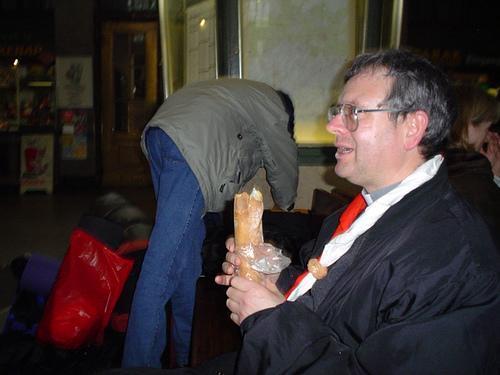How many people are in the picture?
Give a very brief answer. 3. How many umbrellas are seen?
Give a very brief answer. 0. 